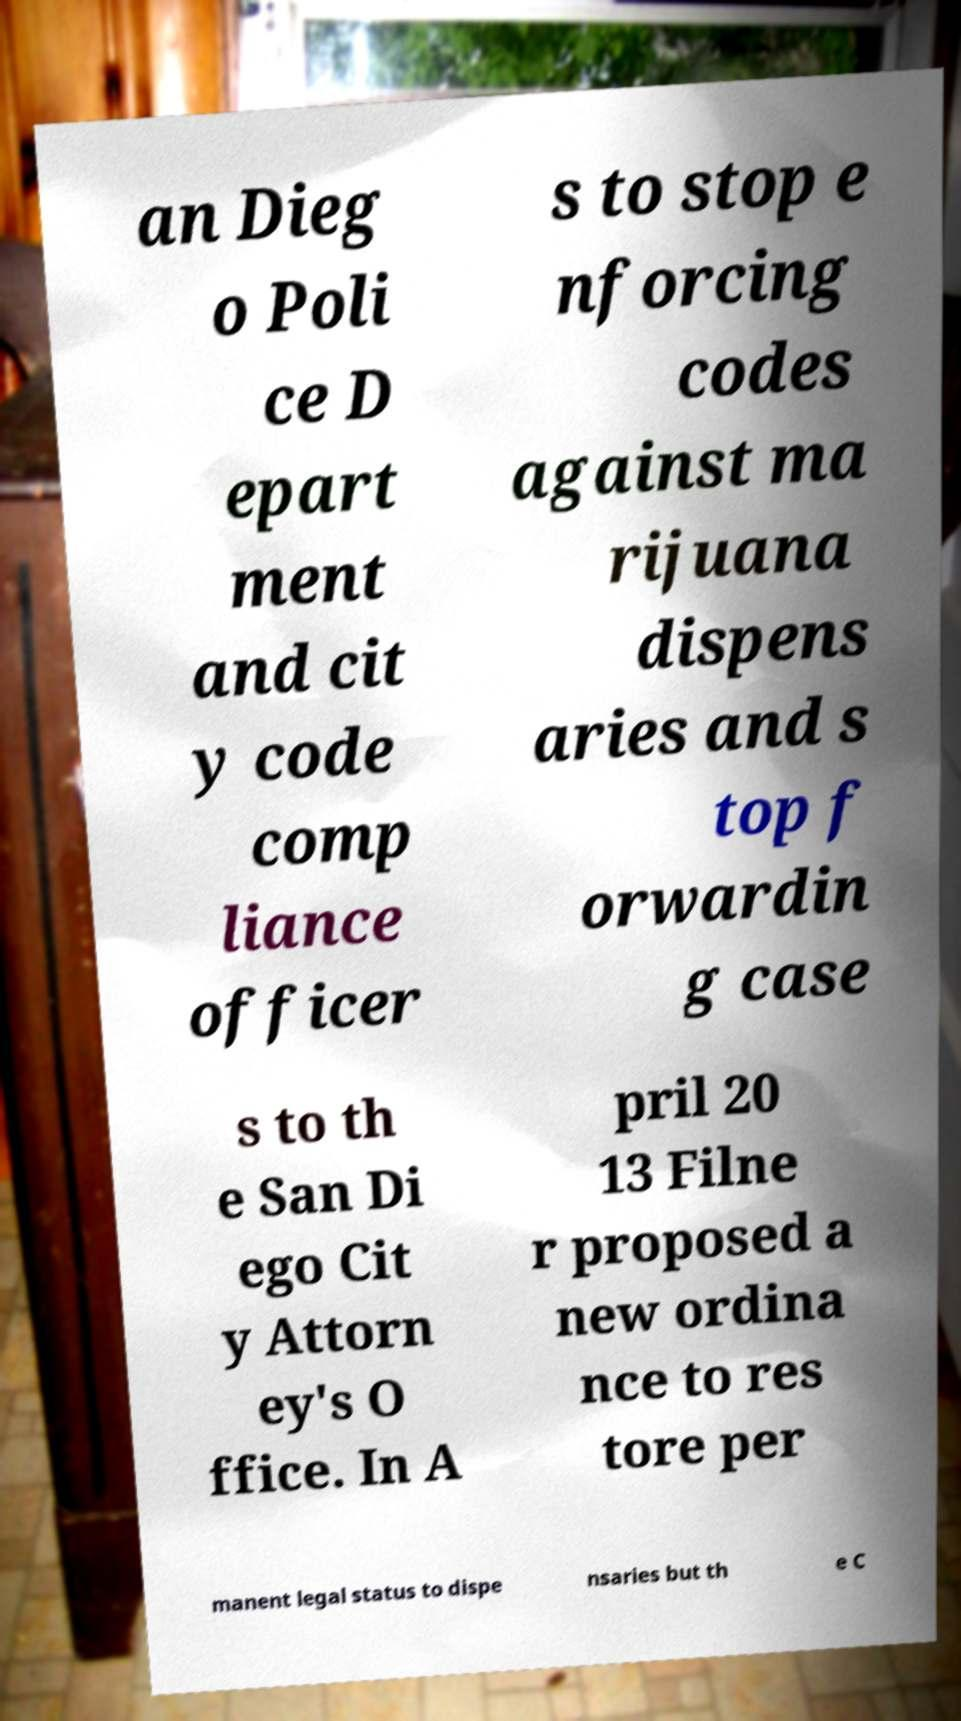Could you extract and type out the text from this image? an Dieg o Poli ce D epart ment and cit y code comp liance officer s to stop e nforcing codes against ma rijuana dispens aries and s top f orwardin g case s to th e San Di ego Cit y Attorn ey's O ffice. In A pril 20 13 Filne r proposed a new ordina nce to res tore per manent legal status to dispe nsaries but th e C 